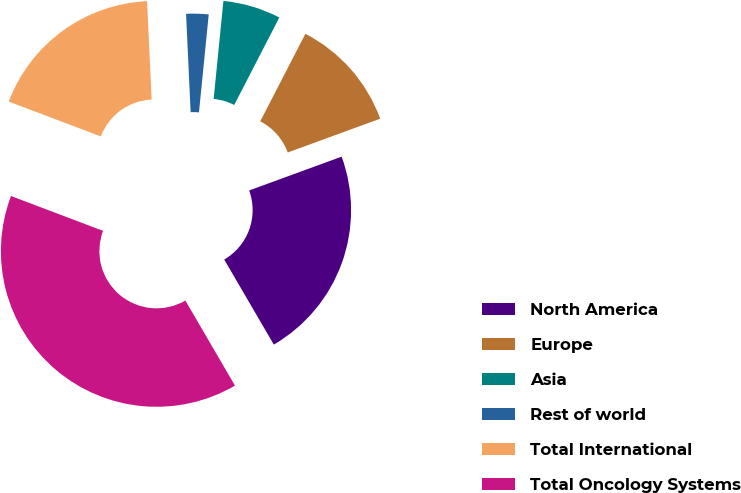Convert chart. <chart><loc_0><loc_0><loc_500><loc_500><pie_chart><fcel>North America<fcel>Europe<fcel>Asia<fcel>Rest of world<fcel>Total International<fcel>Total Oncology Systems<nl><fcel>22.18%<fcel>11.84%<fcel>6.0%<fcel>2.32%<fcel>18.5%<fcel>39.16%<nl></chart> 